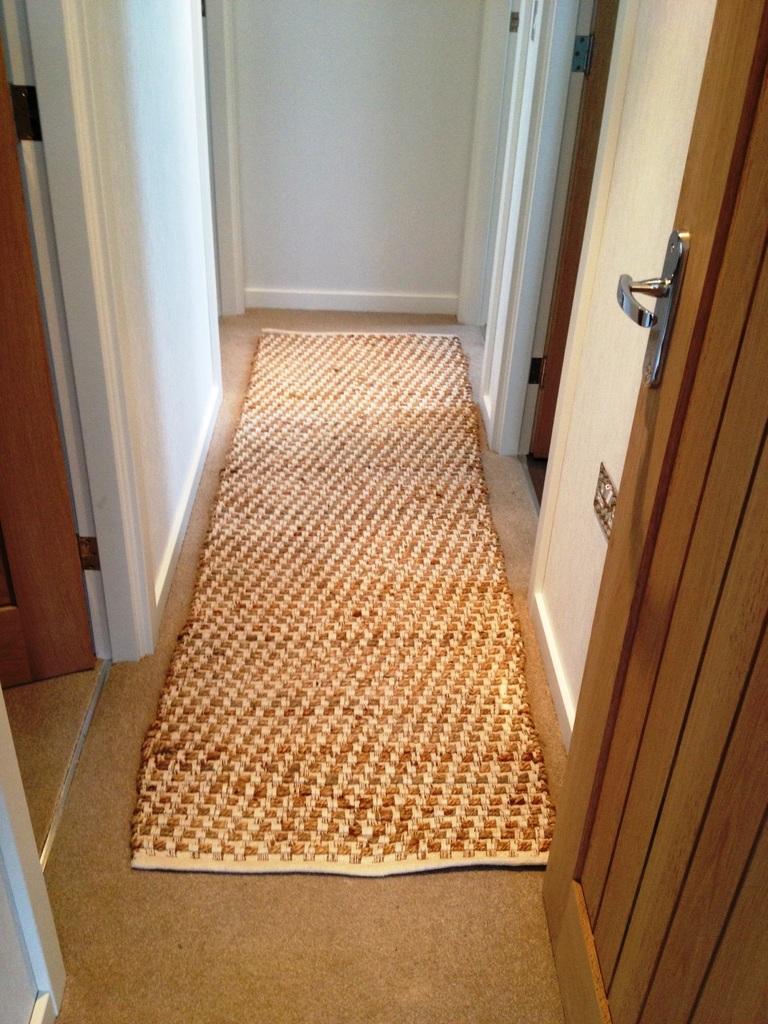How would you summarize this image in a sentence or two? In this picture there is a rug in the center of the image and there are doors on the right and left side of the image. 